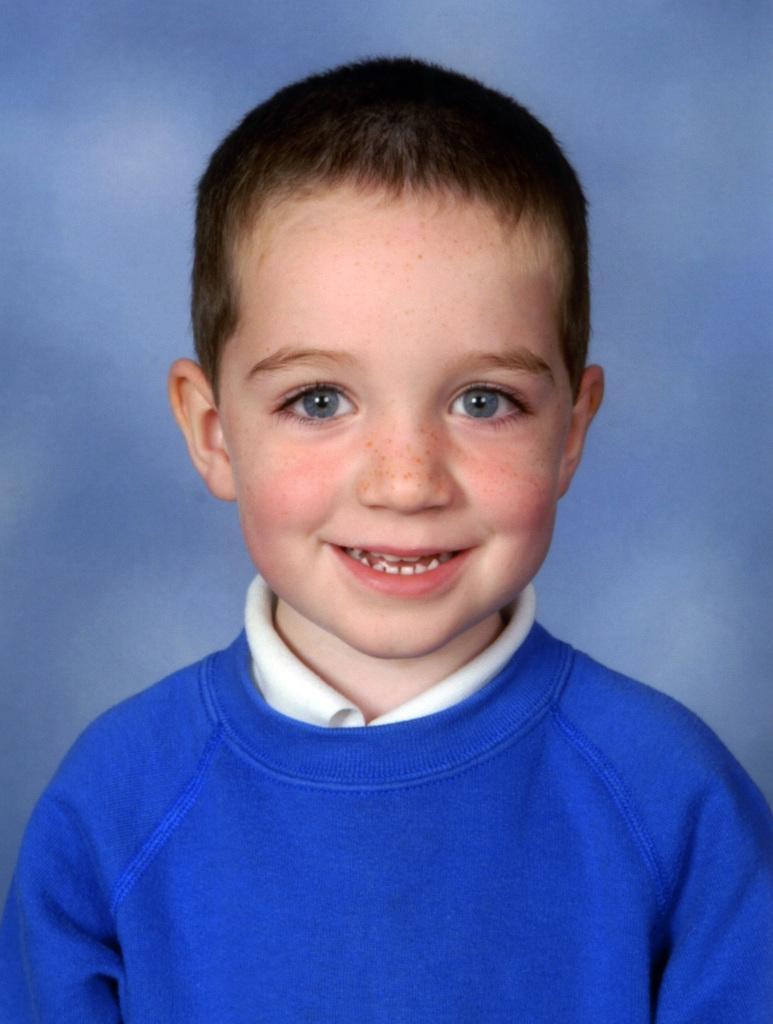Describe this image in one or two sentences. A child is smiling wearing a blue t shirt. 